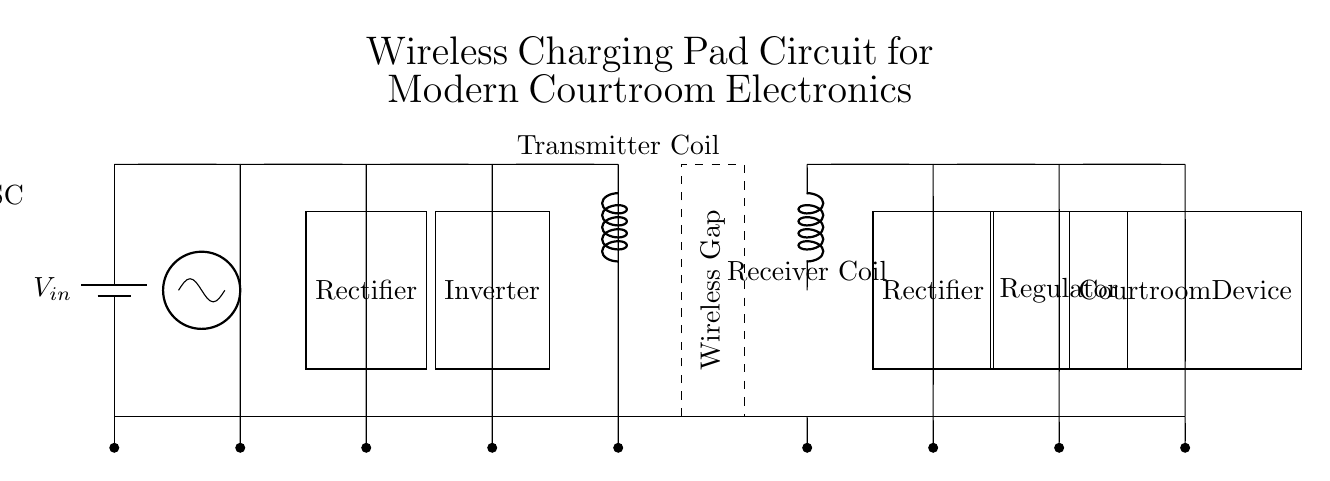What is the power source in this circuit? The circuit uses a battery as the power source, which is shown as the first component marked as V_in.
Answer: Battery What component converts AC to DC in this circuit? The rectifier, located after the oscillator and before the inverter, is responsible for converting the alternating current into direct current.
Answer: Rectifier How many coils are present in this wireless charging circuit? There are two coils in the diagram: the transmitter coil and the receiver coil, indicated by their respective labels.
Answer: Two What is the function of the inverter in this circuit? The inverter's role is to convert DC back to AC after the rectification process, which is necessary for the operation of the transmitter coil.
Answer: Converts DC to AC Which component regulates the voltage for the courtroom device? The voltage regulator, placed before the connection to the courtroom device, ensures that the output voltage is stable and suitable for the device’s operation.
Answer: Regulator What type of circuit is represented here? This is a wireless charging circuit designed for charging devices without direct electrical connections, utilizing inductive charging principles.
Answer: Wireless charging circuit 